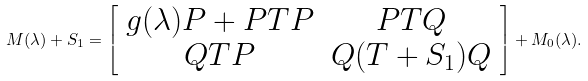<formula> <loc_0><loc_0><loc_500><loc_500>M ( \lambda ) + S _ { 1 } = \left [ \begin{array} { c c } g ( \lambda ) P + P T P & P T Q \\ Q T P & Q ( T + S _ { 1 } ) Q \end{array} \right ] + M _ { 0 } ( \lambda ) .</formula> 